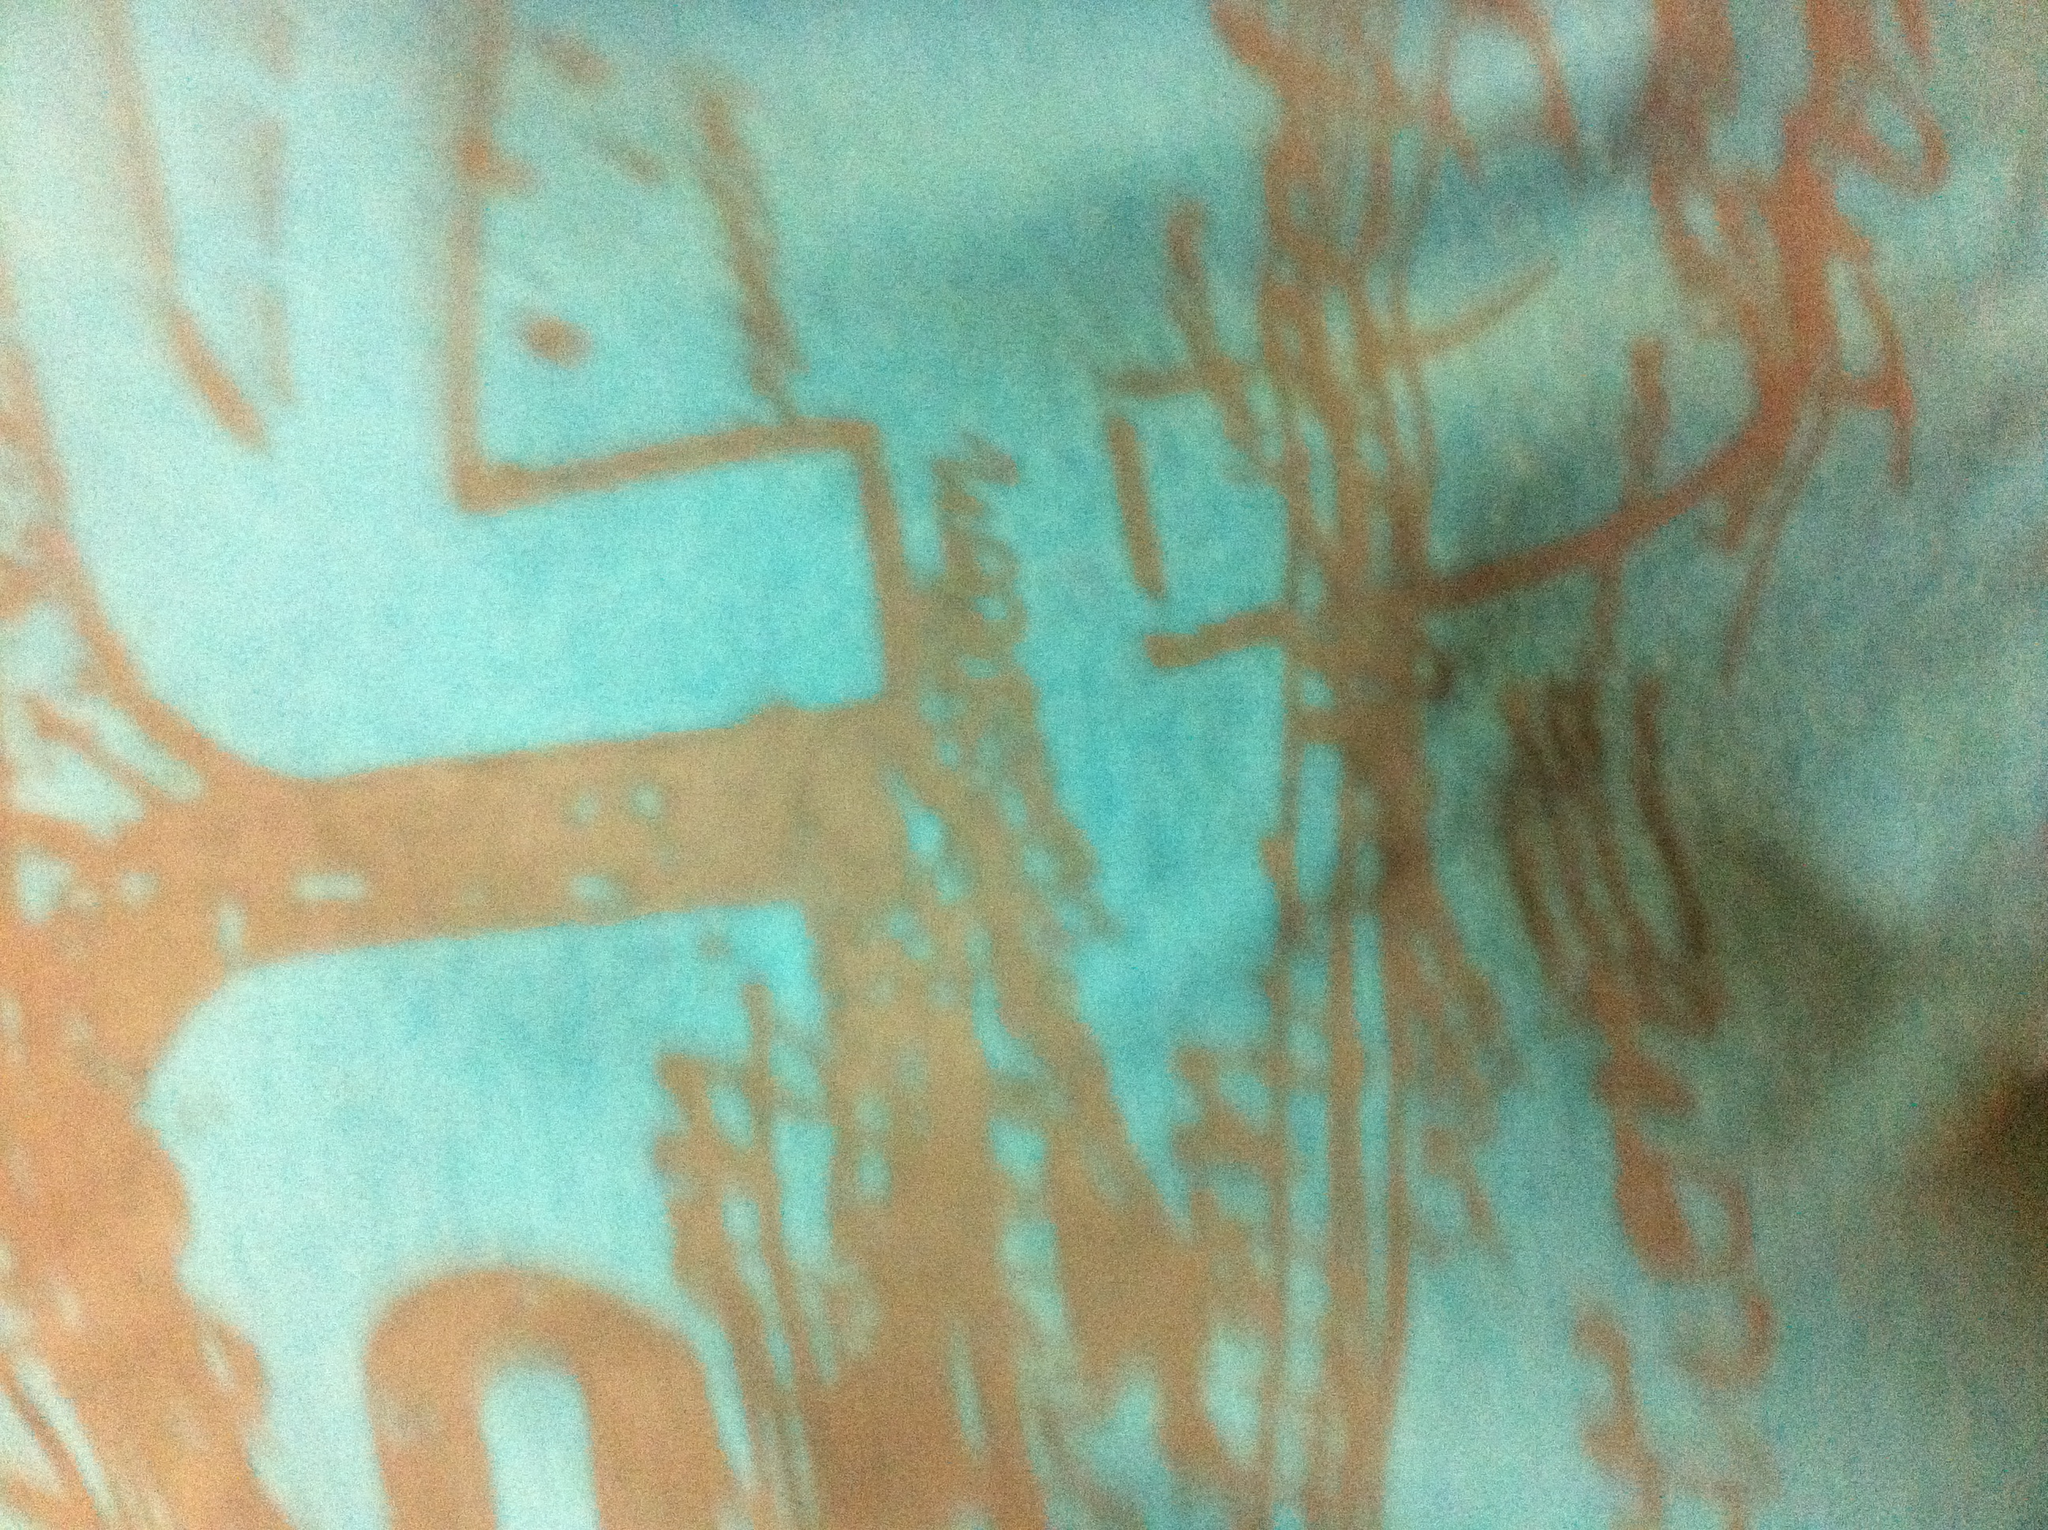Describe the design patterns on the shirt. The shirt features an abstract design with brushstroke-like patterns in a shade of orange or rust against a turquoise or light blue background. The patterns seem random and artistic, giving the shirt a unique and eye-catching appearance. What material might this shirt be made of? Based on the appearance and the visible texture in the image, the shirt could be made of a lightweight, breathable fabric like cotton or a poly-cotton blend. These materials are common for casual wear and can hold designs well. 